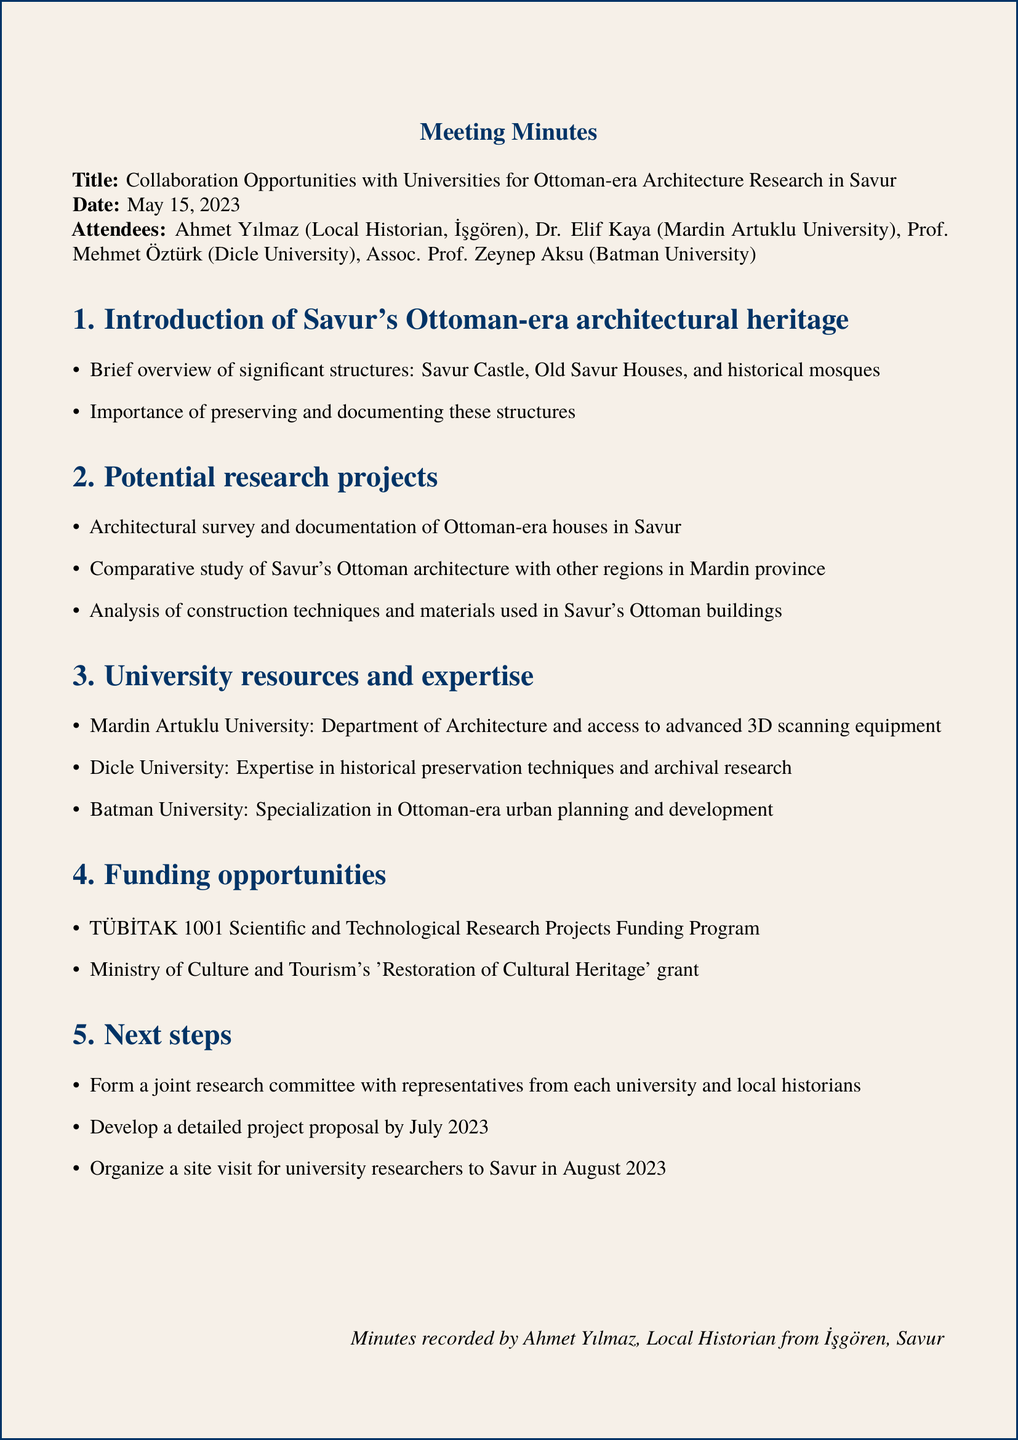what is the date of the meeting? The date of the meeting is explicitly mentioned in the document.
Answer: May 15, 2023 who is the local historian attending the meeting? The document lists the attendees, including the local historian.
Answer: Ahmet Yılmaz which university specializes in Ottoman-era urban planning? The university's specialization is mentioned in the section detailing university resources.
Answer: Batman University what are the two funding opportunities listed? The document states specific funding opportunities under a dedicated agenda item.
Answer: TÜBİTAK 1001 and Ministry of Culture and Tourism's grant what is one potential research project mentioned? A potential research project is outlined in the document under the agenda items.
Answer: Architectural survey and documentation of Ottoman-era houses in Savur how many universities were represented at the meeting? The total number of attendees includes four university representatives.
Answer: Three when is the detailed project proposal due? The document specifies a deadline for the project proposal.
Answer: July 2023 what is the organizational structure proposed for the next steps? The document specifies forming a committee for future collaboration.
Answer: Joint research committee 